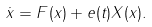<formula> <loc_0><loc_0><loc_500><loc_500>\dot { x } = F ( x ) + e ( t ) X ( x ) .</formula> 